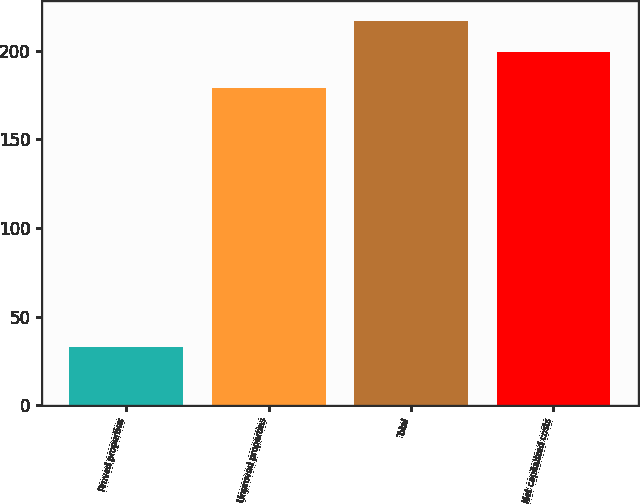Convert chart. <chart><loc_0><loc_0><loc_500><loc_500><bar_chart><fcel>Proved properties<fcel>Unproved properties<fcel>Total<fcel>Net capitalized costs<nl><fcel>33<fcel>179<fcel>216.9<fcel>199<nl></chart> 